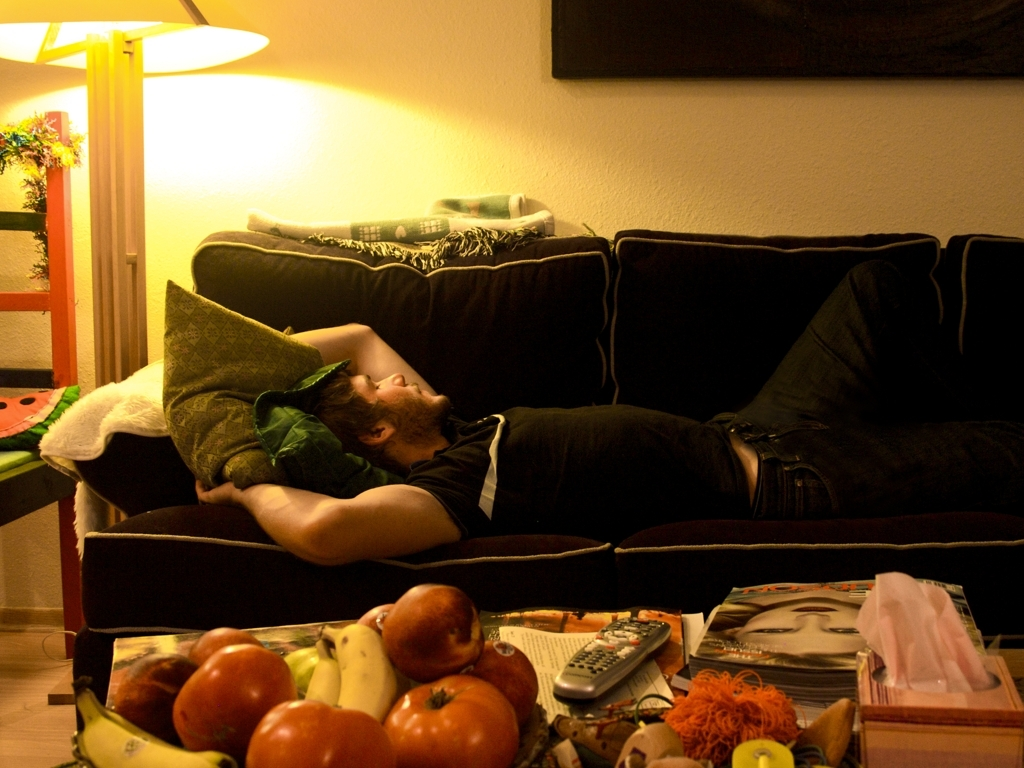What activities might have taken place in this room recently? The arrangement of the cushions and the person laying on the couch suggest relaxation or perhaps a nap. The presence of fruit and magazines on the table indicates someone might have been enjoying a healthy snack while reading or watching TV. Can you describe the mood of the room based on the lighting and the colors present? The warm lighting and the soft glow of the lamp create a cozy and comfortable atmosphere. The darker hues of the furniture contrast with the lighter walls, which could suggest a calm and inviting environment ideal for relaxation. 